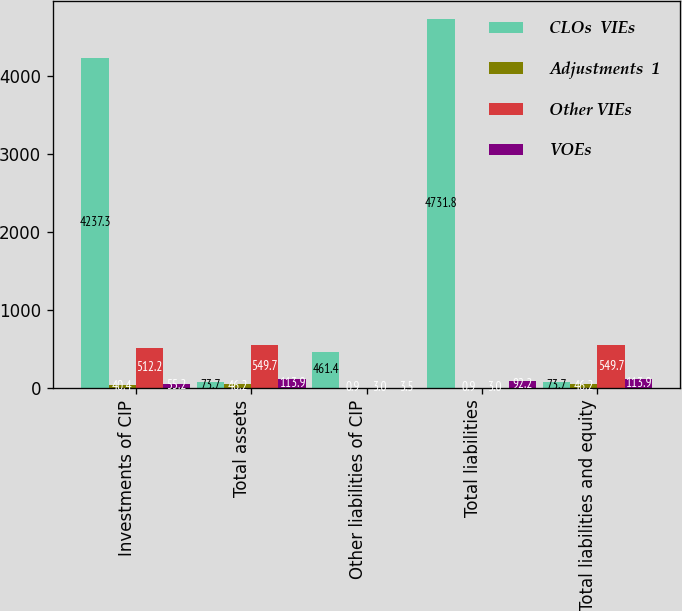Convert chart. <chart><loc_0><loc_0><loc_500><loc_500><stacked_bar_chart><ecel><fcel>Investments of CIP<fcel>Total assets<fcel>Other liabilities of CIP<fcel>Total liabilities<fcel>Total liabilities and equity<nl><fcel>CLOs  VIEs<fcel>4237.3<fcel>73.7<fcel>461.4<fcel>4731.8<fcel>73.7<nl><fcel>Adjustments  1<fcel>40.4<fcel>46.2<fcel>0.9<fcel>0.9<fcel>46.2<nl><fcel>Other VIEs<fcel>512.2<fcel>549.7<fcel>3<fcel>3<fcel>549.7<nl><fcel>VOEs<fcel>55.2<fcel>113.9<fcel>3.5<fcel>92.2<fcel>113.9<nl></chart> 